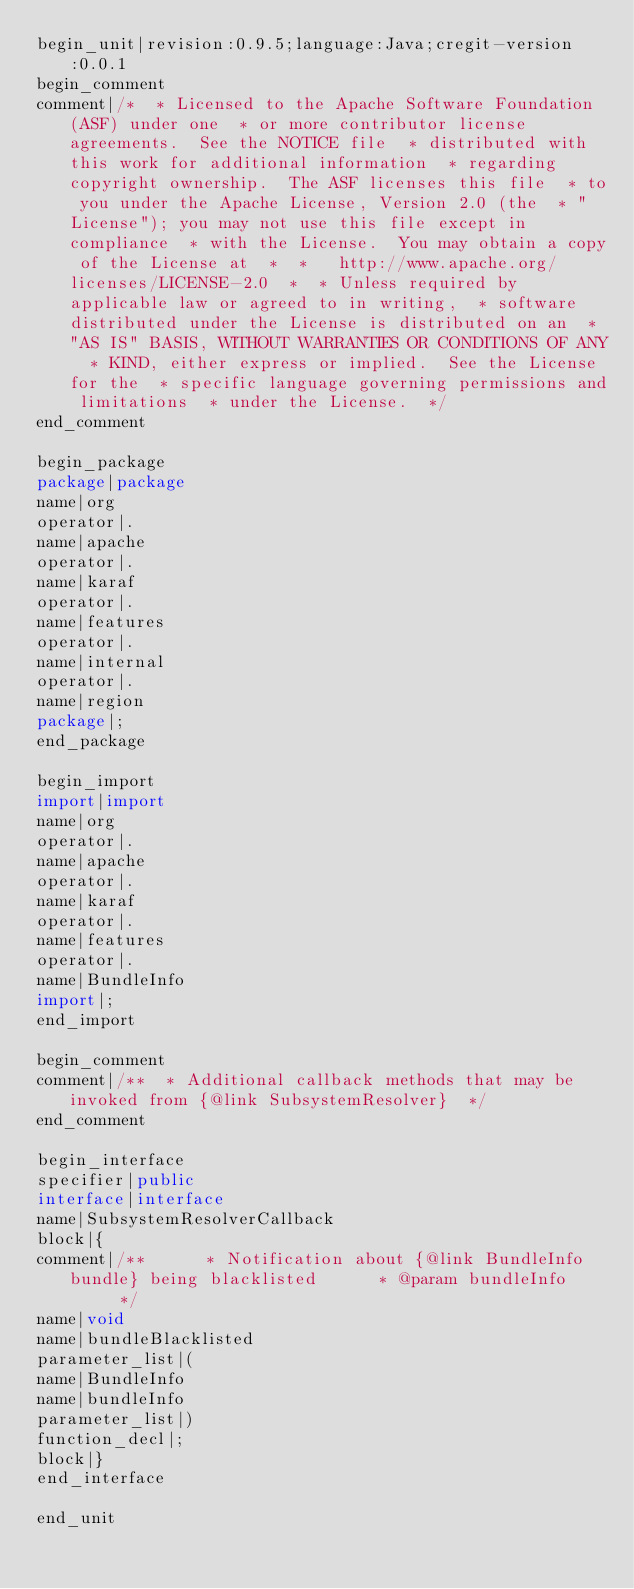Convert code to text. <code><loc_0><loc_0><loc_500><loc_500><_Java_>begin_unit|revision:0.9.5;language:Java;cregit-version:0.0.1
begin_comment
comment|/*  * Licensed to the Apache Software Foundation (ASF) under one  * or more contributor license agreements.  See the NOTICE file  * distributed with this work for additional information  * regarding copyright ownership.  The ASF licenses this file  * to you under the Apache License, Version 2.0 (the  * "License"); you may not use this file except in compliance  * with the License.  You may obtain a copy of the License at  *  *   http://www.apache.org/licenses/LICENSE-2.0  *  * Unless required by applicable law or agreed to in writing,  * software distributed under the License is distributed on an  * "AS IS" BASIS, WITHOUT WARRANTIES OR CONDITIONS OF ANY  * KIND, either express or implied.  See the License for the  * specific language governing permissions and limitations  * under the License.  */
end_comment

begin_package
package|package
name|org
operator|.
name|apache
operator|.
name|karaf
operator|.
name|features
operator|.
name|internal
operator|.
name|region
package|;
end_package

begin_import
import|import
name|org
operator|.
name|apache
operator|.
name|karaf
operator|.
name|features
operator|.
name|BundleInfo
import|;
end_import

begin_comment
comment|/**  * Additional callback methods that may be invoked from {@link SubsystemResolver}  */
end_comment

begin_interface
specifier|public
interface|interface
name|SubsystemResolverCallback
block|{
comment|/**      * Notification about {@link BundleInfo bundle} being blacklisted      * @param bundleInfo      */
name|void
name|bundleBlacklisted
parameter_list|(
name|BundleInfo
name|bundleInfo
parameter_list|)
function_decl|;
block|}
end_interface

end_unit

</code> 